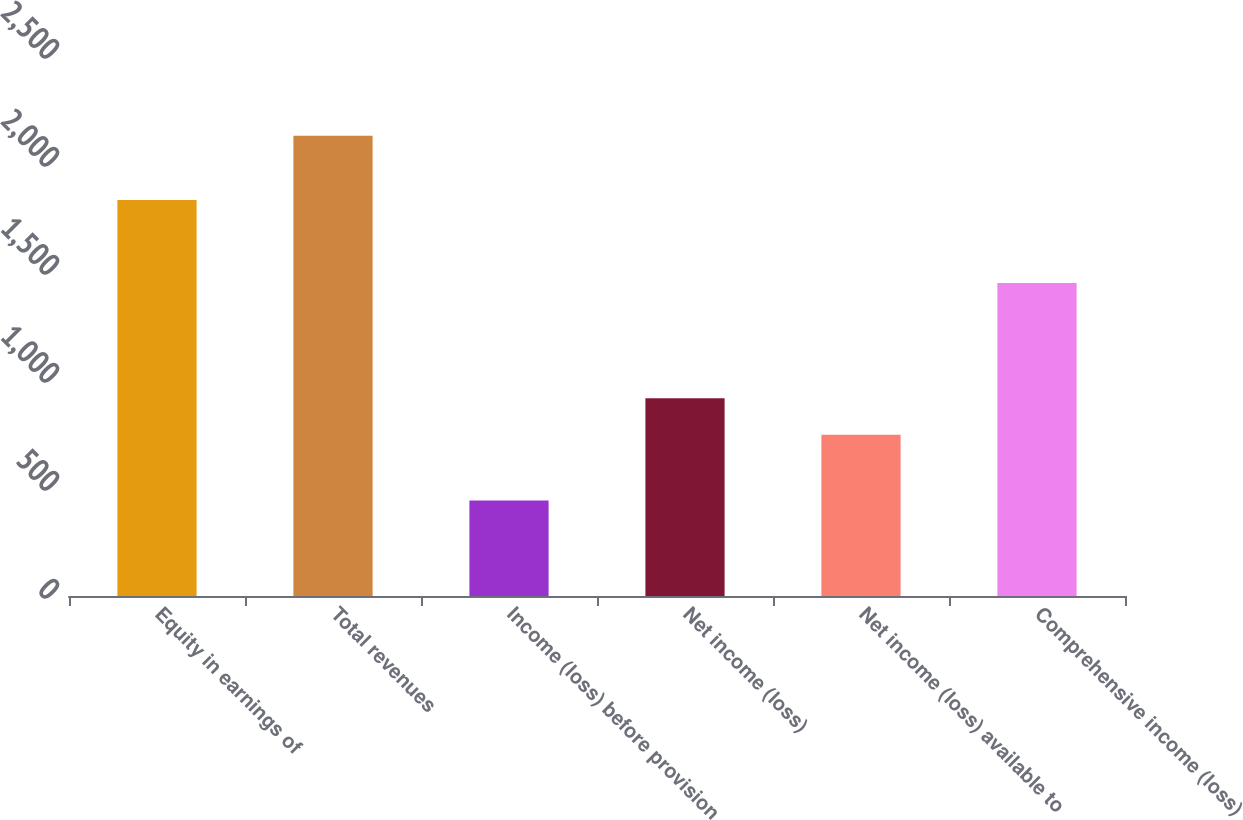<chart> <loc_0><loc_0><loc_500><loc_500><bar_chart><fcel>Equity in earnings of<fcel>Total revenues<fcel>Income (loss) before provision<fcel>Net income (loss)<fcel>Net income (loss) available to<fcel>Comprehensive income (loss)<nl><fcel>1833<fcel>2131<fcel>442<fcel>915.9<fcel>747<fcel>1449<nl></chart> 